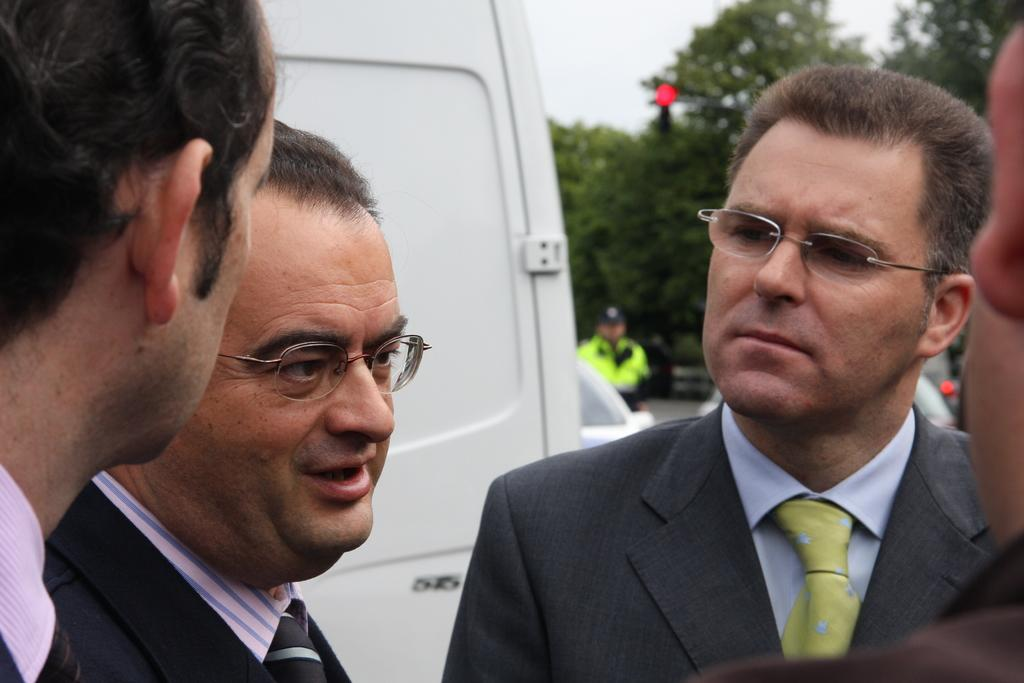What can be seen in the foreground of the image? There are men standing in the foreground of the image. What are the men wearing? The men are wearing coats. What is visible in the background of the image? There is a vehicle, trees, and a pole in the background of the image. What is visible at the top of the image? The sky is visible at the top of the image. What type of metal is used to make the pizzas in the image? There are no pizzas present in the image, so it is not possible to determine what type of metal might be used to make them. 